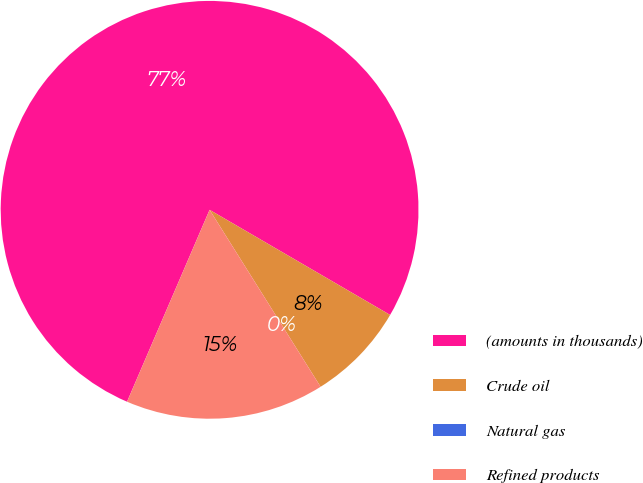Convert chart to OTSL. <chart><loc_0><loc_0><loc_500><loc_500><pie_chart><fcel>(amounts in thousands)<fcel>Crude oil<fcel>Natural gas<fcel>Refined products<nl><fcel>76.92%<fcel>7.69%<fcel>0.0%<fcel>15.38%<nl></chart> 